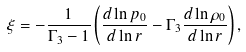Convert formula to latex. <formula><loc_0><loc_0><loc_500><loc_500>\xi = - \frac { 1 } { \Gamma _ { 3 } - 1 } \left ( \frac { d \ln { p _ { 0 } } } { d \ln { r } } - \Gamma _ { 3 } \frac { d \ln { \rho } _ { 0 } } { d \ln { r } } \right ) ,</formula> 